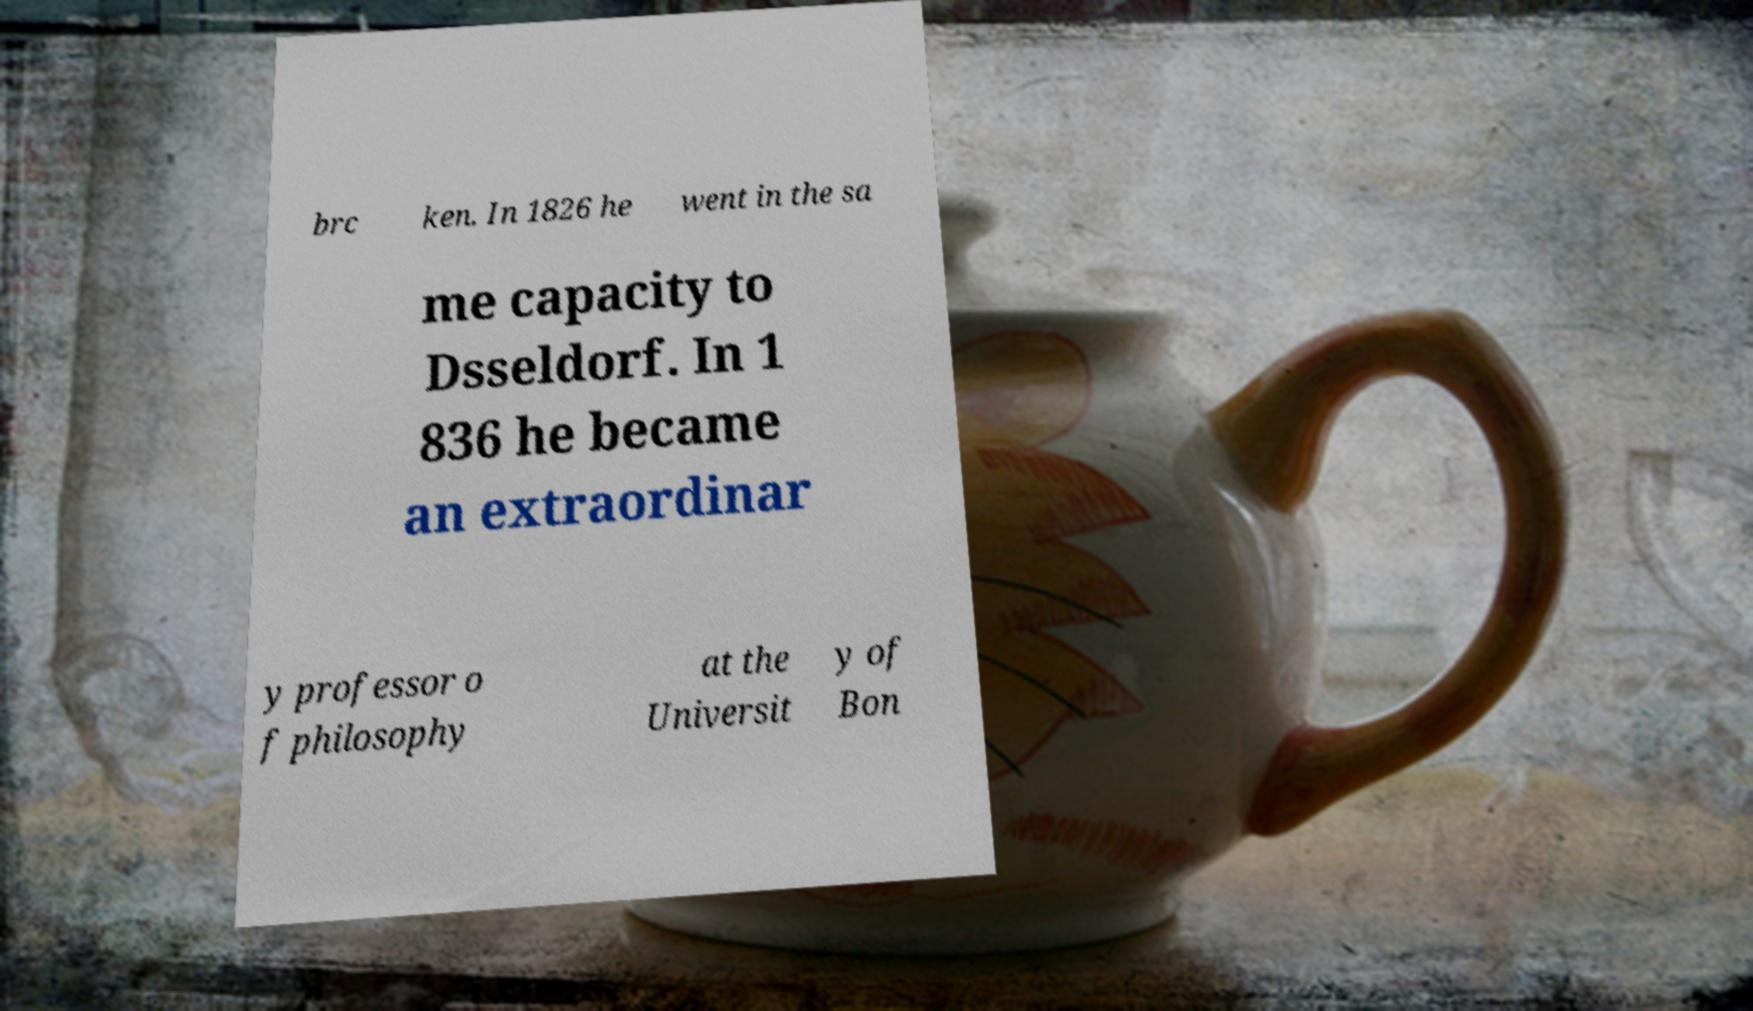Can you read and provide the text displayed in the image?This photo seems to have some interesting text. Can you extract and type it out for me? brc ken. In 1826 he went in the sa me capacity to Dsseldorf. In 1 836 he became an extraordinar y professor o f philosophy at the Universit y of Bon 